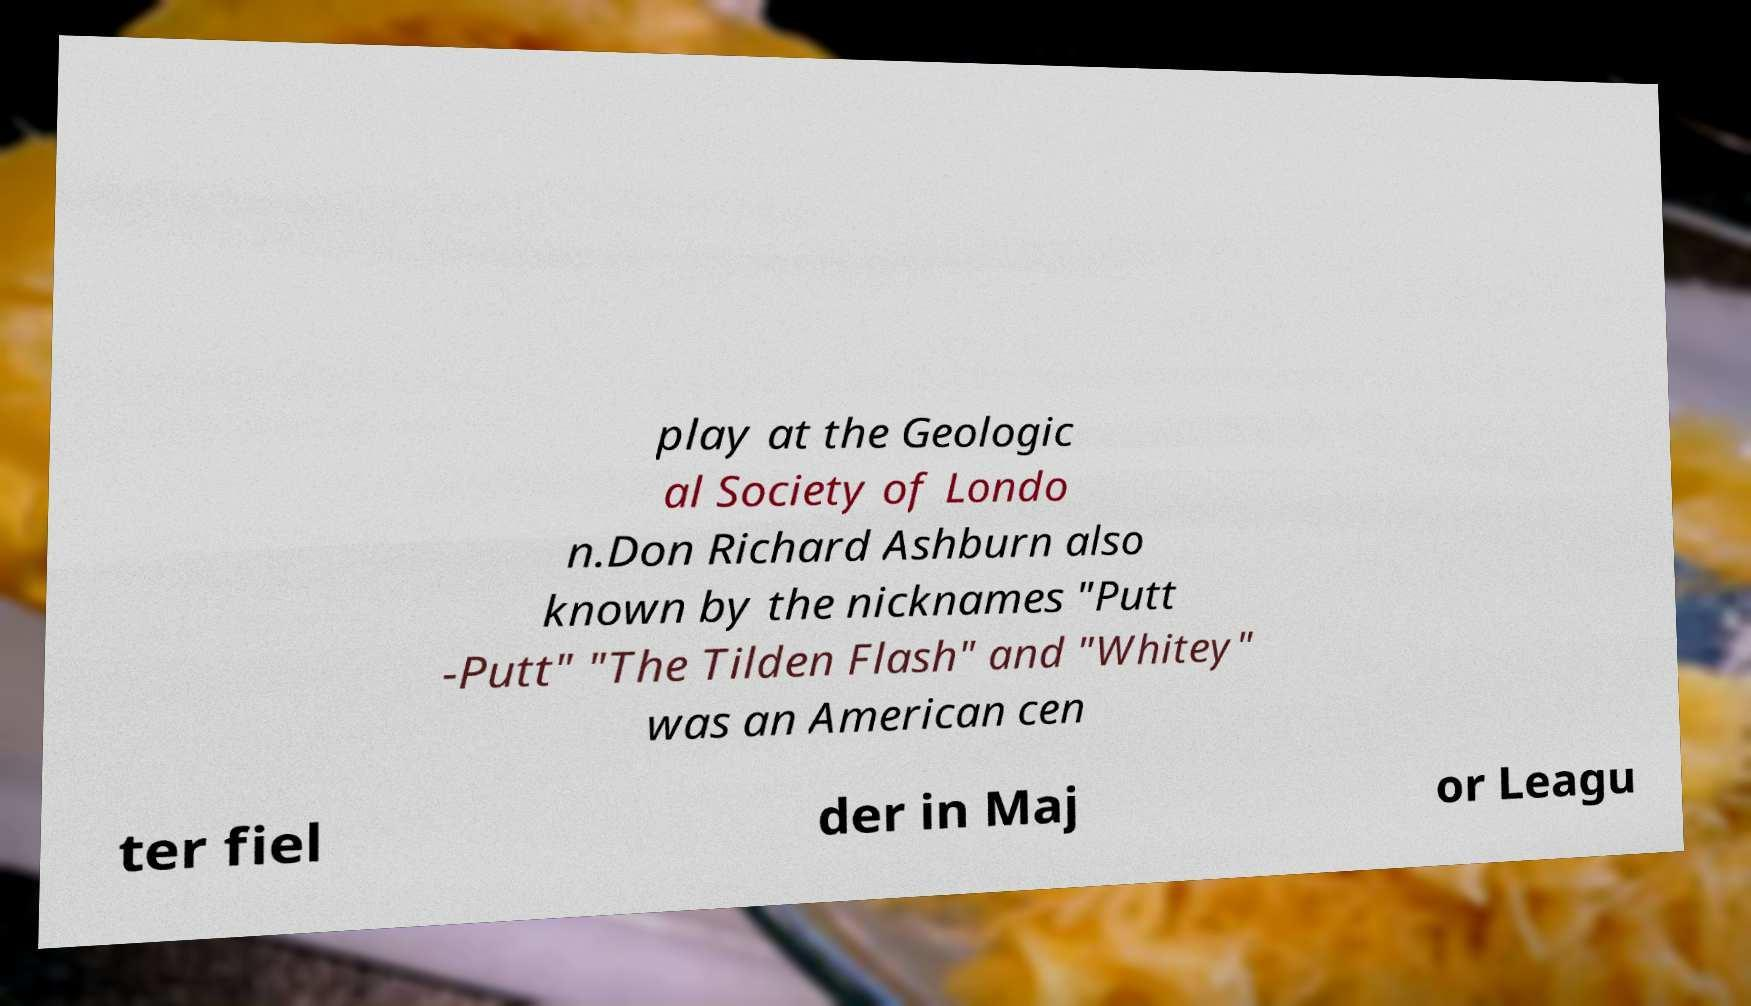There's text embedded in this image that I need extracted. Can you transcribe it verbatim? play at the Geologic al Society of Londo n.Don Richard Ashburn also known by the nicknames "Putt -Putt" "The Tilden Flash" and "Whitey" was an American cen ter fiel der in Maj or Leagu 